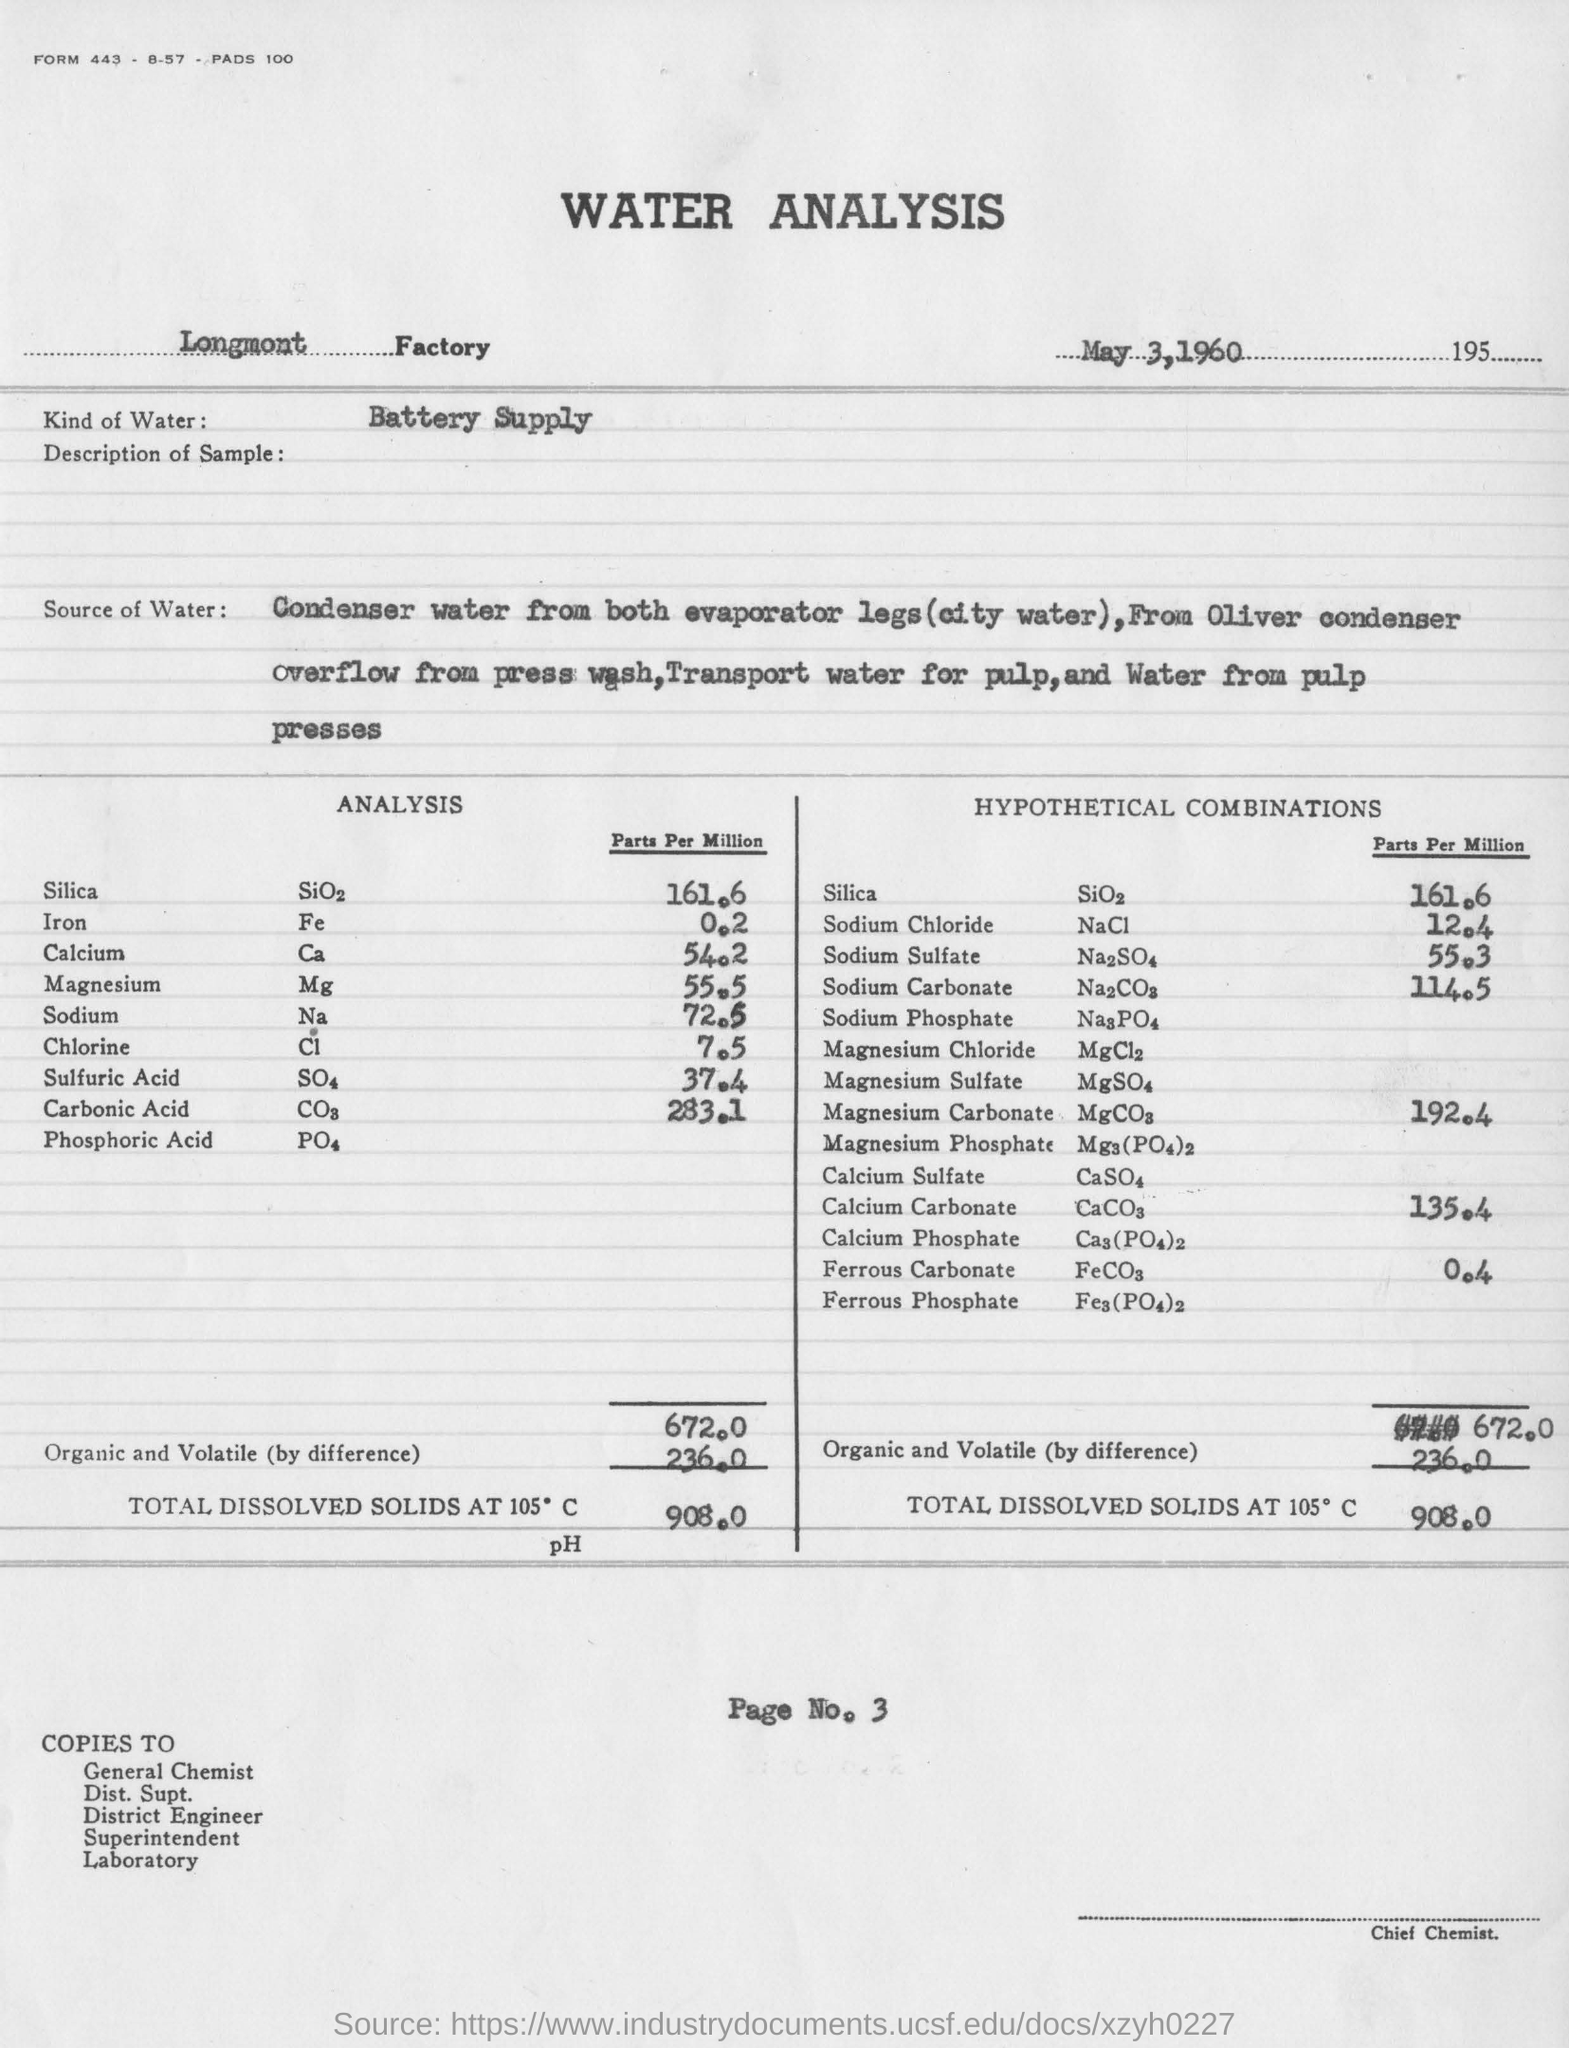What is the date of this report?
Your response must be concise. May 3, 1960. What is the kind of water?
Your answer should be compact. Battery supply. 